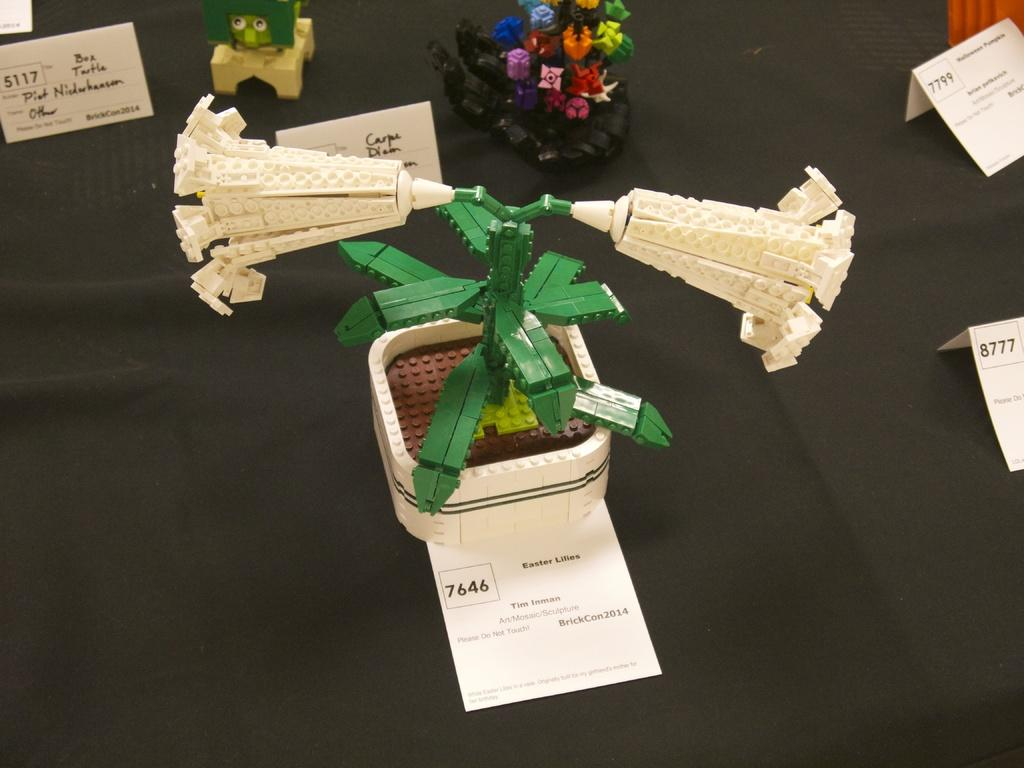What is the color of the surface on which the objects are placed in the image? The surface is black. What type of information can be found about the objects in the image? There are description papers about the objects in the image. How much is the payment for the faucet in the image? There is no faucet present in the image, so it is not possible to determine the payment for it. 